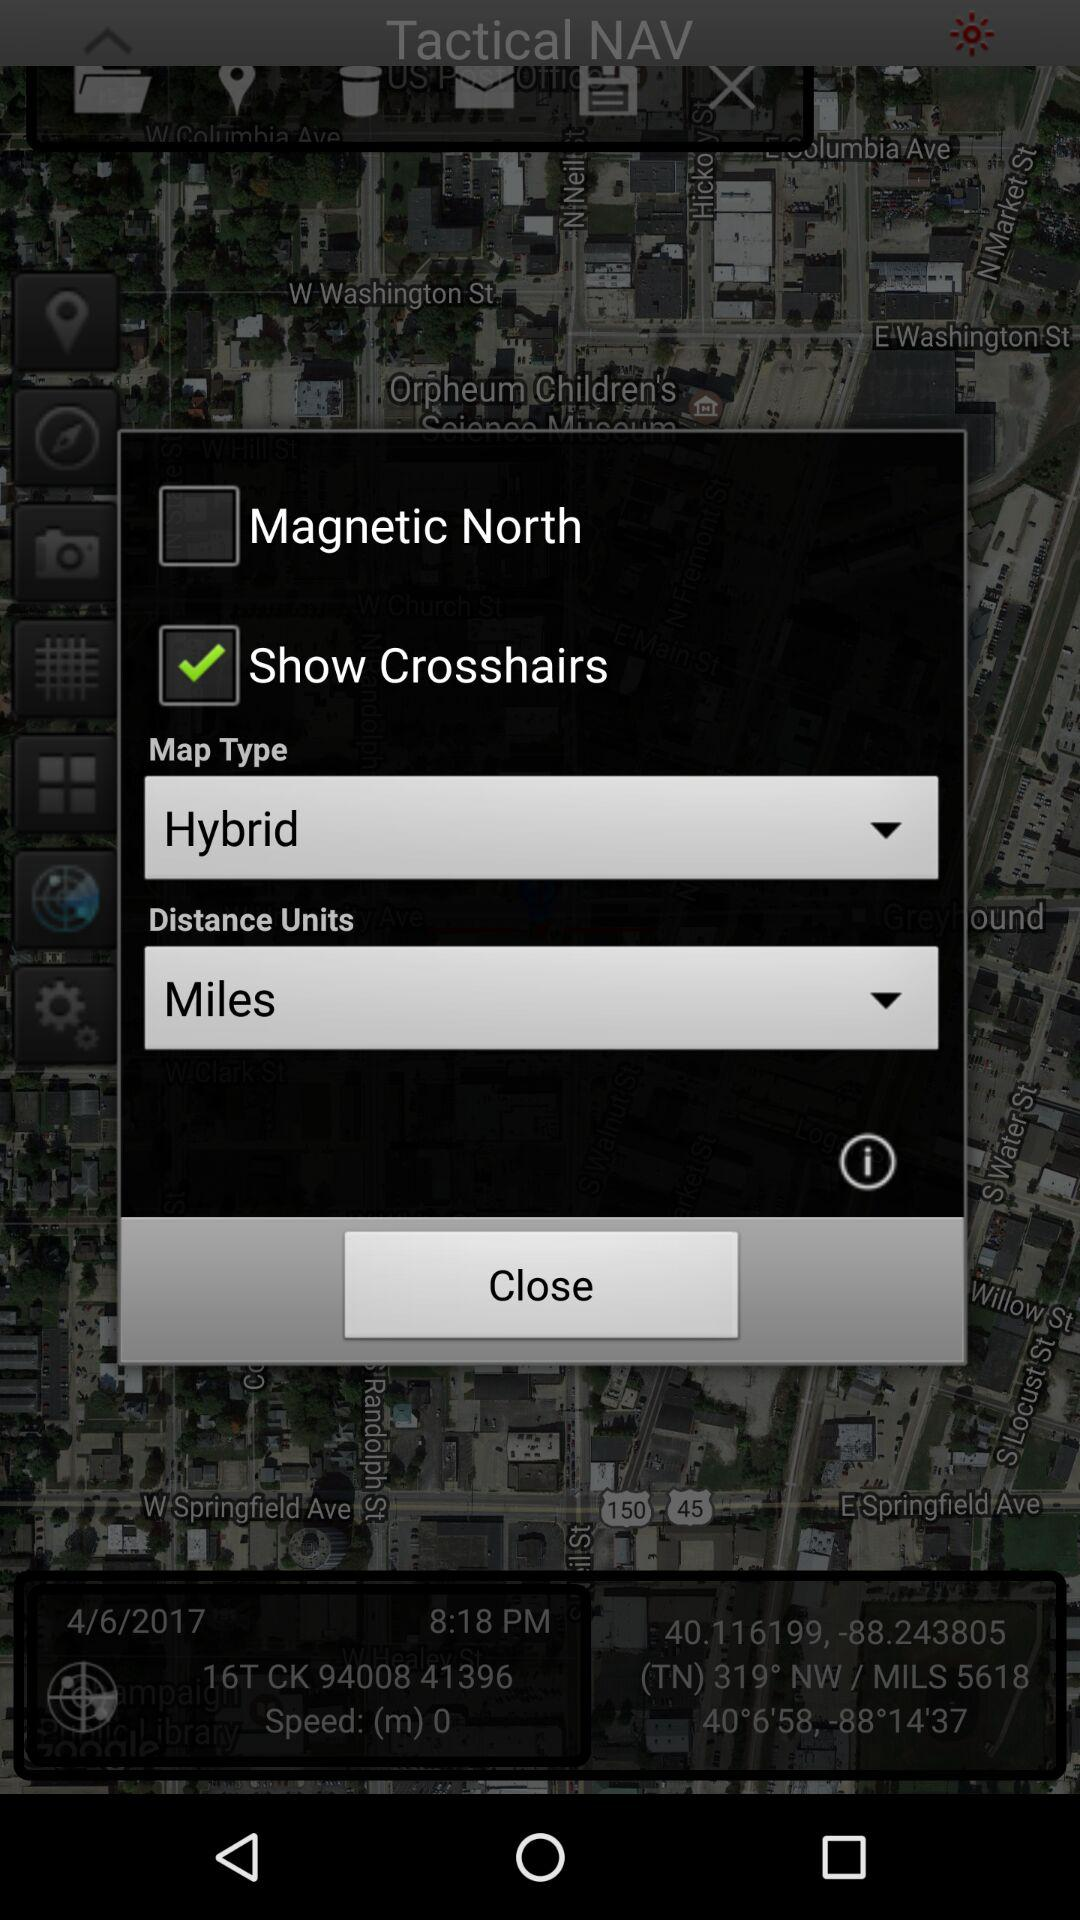What is the distance unit? The distance unit is miles. 